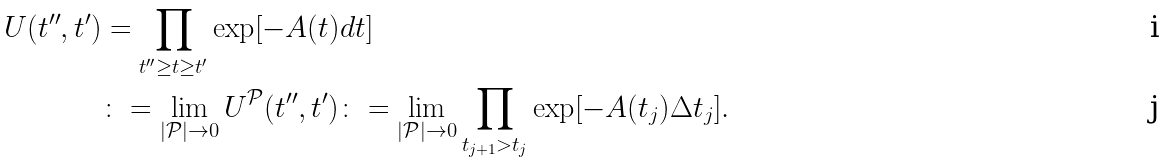Convert formula to latex. <formula><loc_0><loc_0><loc_500><loc_500>U ( t ^ { \prime \prime } , t ^ { \prime } ) & = \prod _ { t ^ { \prime \prime } \geq t \geq t ^ { \prime } } \exp [ - A ( t ) d t ] \\ & \colon = \lim _ { | { \mathcal { P } } | \rightarrow 0 } U ^ { \mathcal { P } } ( t ^ { \prime \prime } , t ^ { \prime } ) \colon = \lim _ { | { \mathcal { P } } | \rightarrow 0 } \prod _ { t _ { j + 1 } > t _ { j } } \exp [ - A ( t _ { j } ) \Delta t _ { j } ] .</formula> 